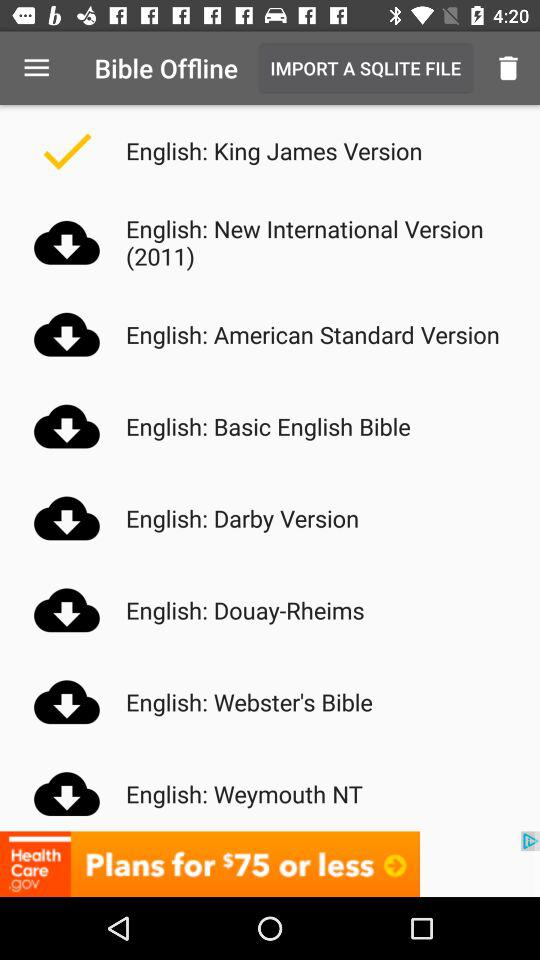How many versions of the Bible are available?
Answer the question using a single word or phrase. 8 